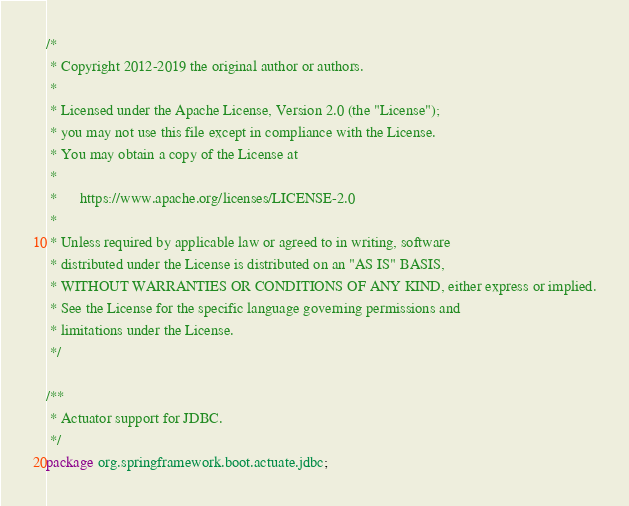Convert code to text. <code><loc_0><loc_0><loc_500><loc_500><_Java_>/*
 * Copyright 2012-2019 the original author or authors.
 *
 * Licensed under the Apache License, Version 2.0 (the "License");
 * you may not use this file except in compliance with the License.
 * You may obtain a copy of the License at
 *
 *      https://www.apache.org/licenses/LICENSE-2.0
 *
 * Unless required by applicable law or agreed to in writing, software
 * distributed under the License is distributed on an "AS IS" BASIS,
 * WITHOUT WARRANTIES OR CONDITIONS OF ANY KIND, either express or implied.
 * See the License for the specific language governing permissions and
 * limitations under the License.
 */

/**
 * Actuator support for JDBC.
 */
package org.springframework.boot.actuate.jdbc;
</code> 